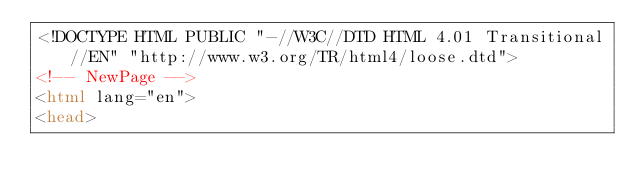<code> <loc_0><loc_0><loc_500><loc_500><_HTML_><!DOCTYPE HTML PUBLIC "-//W3C//DTD HTML 4.01 Transitional//EN" "http://www.w3.org/TR/html4/loose.dtd">
<!-- NewPage -->
<html lang="en">
<head></code> 